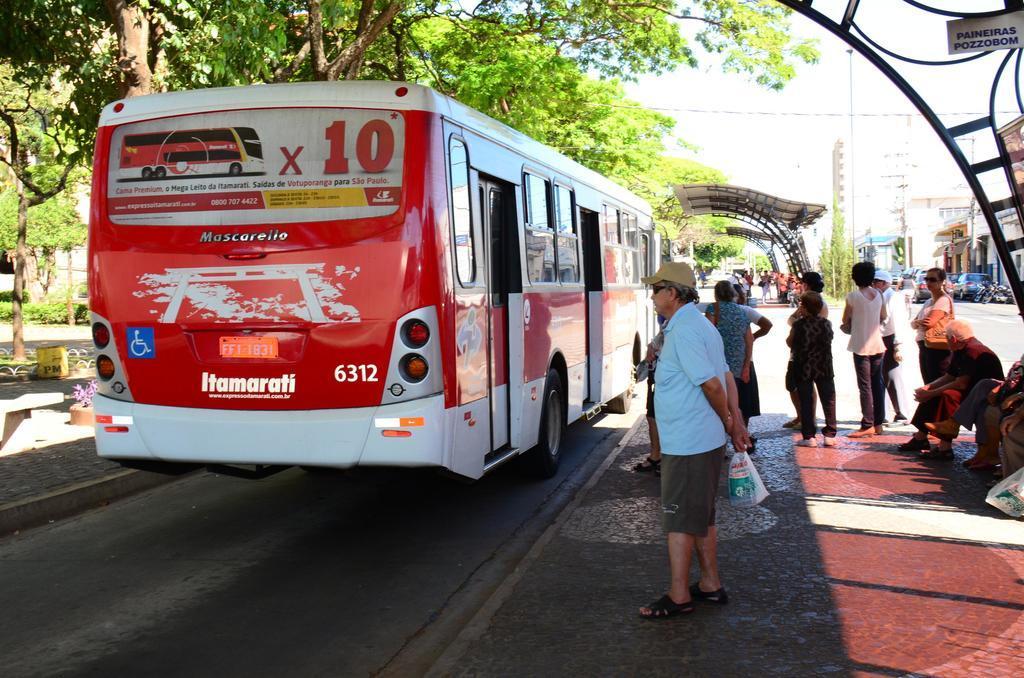Can you describe this image briefly? In this picture we can see a bus on the road, trees, houses, shelters, vehicles, plastic covers and a group of people where some are standing and some are sitting and in the background we can see the sky. 